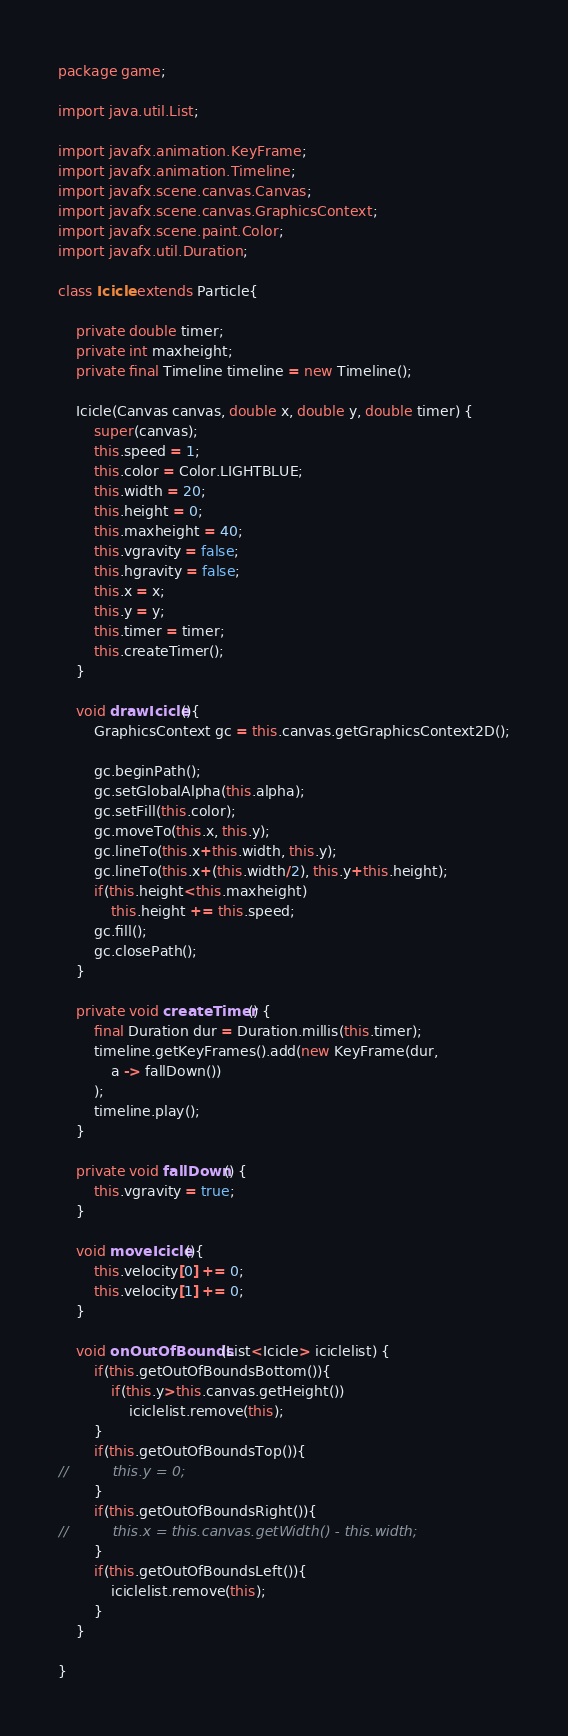Convert code to text. <code><loc_0><loc_0><loc_500><loc_500><_Java_>package game;

import java.util.List;

import javafx.animation.KeyFrame;
import javafx.animation.Timeline;
import javafx.scene.canvas.Canvas;
import javafx.scene.canvas.GraphicsContext;
import javafx.scene.paint.Color;
import javafx.util.Duration;

class Icicle extends Particle{
	
	private double timer;
	private int maxheight;
	private final Timeline timeline = new Timeline();

	Icicle(Canvas canvas, double x, double y, double timer) {
		super(canvas);
		this.speed = 1;
		this.color = Color.LIGHTBLUE;
		this.width = 20;
		this.height = 0;
		this.maxheight = 40;
		this.vgravity = false;
		this.hgravity = false;
		this.x = x;
		this.y = y;
		this.timer = timer;
		this.createTimer();
	}
	
	void drawIcicle(){
		GraphicsContext gc = this.canvas.getGraphicsContext2D();
		
		gc.beginPath();
		gc.setGlobalAlpha(this.alpha);
		gc.setFill(this.color);
		gc.moveTo(this.x, this.y);
		gc.lineTo(this.x+this.width, this.y);
		gc.lineTo(this.x+(this.width/2), this.y+this.height);
		if(this.height<this.maxheight)
			this.height += this.speed;
		gc.fill();
		gc.closePath();
	}
	
	private void createTimer() {
		final Duration dur = Duration.millis(this.timer);
		timeline.getKeyFrames().add(new KeyFrame(dur,
			a -> fallDown())
		);
		timeline.play();
	}
	
	private void fallDown() {
		this.vgravity = true;
	}
	
	void moveIcicle(){
		this.velocity[0] += 0;
		this.velocity[1] += 0;
	}

	void onOutOfBounds(List<Icicle> iciclelist) {
		if(this.getOutOfBoundsBottom()){
			if(this.y>this.canvas.getHeight())
				iciclelist.remove(this);
		}
		if(this.getOutOfBoundsTop()){
//			this.y = 0;
		}
		if(this.getOutOfBoundsRight()){
//			this.x = this.canvas.getWidth() - this.width;
		}
		if(this.getOutOfBoundsLeft()){
			iciclelist.remove(this);
		}
	}

}
</code> 